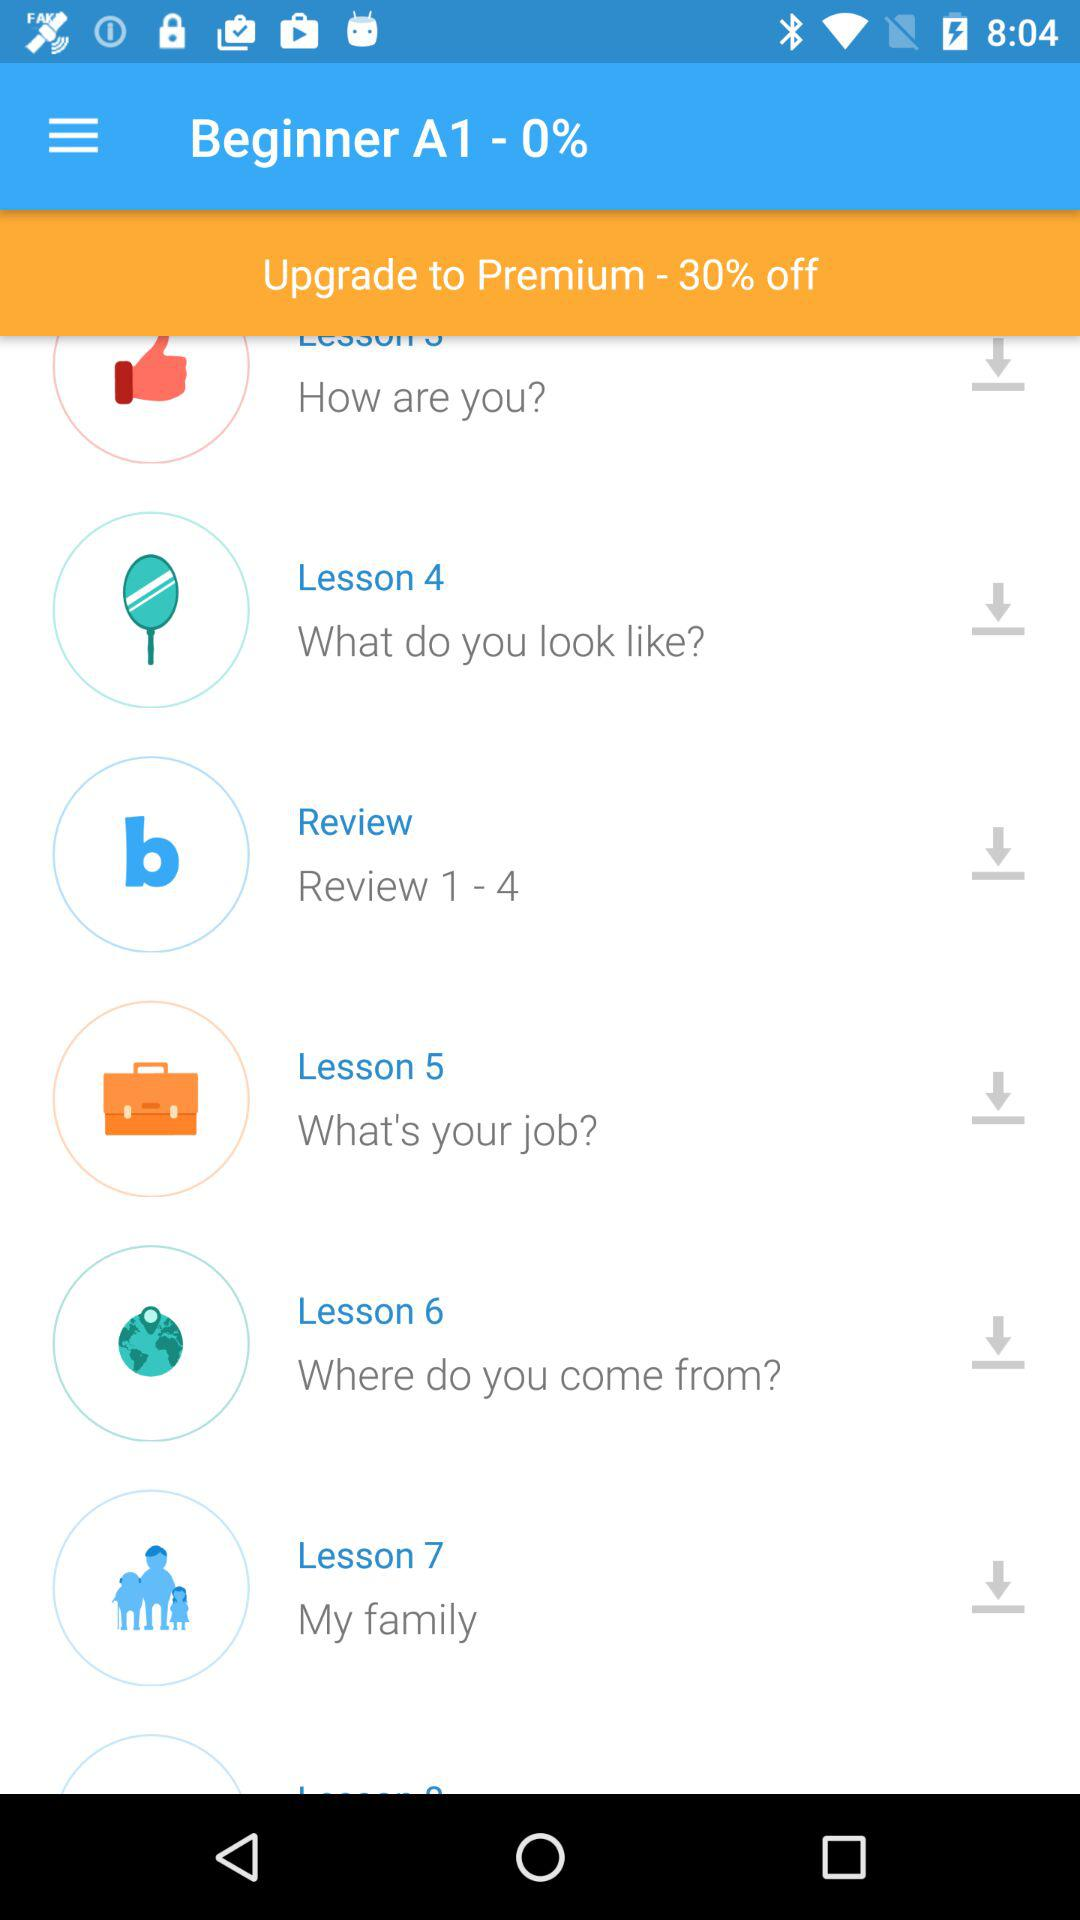What is lesson 6? The lesson 6 is "Where do you come from?". 